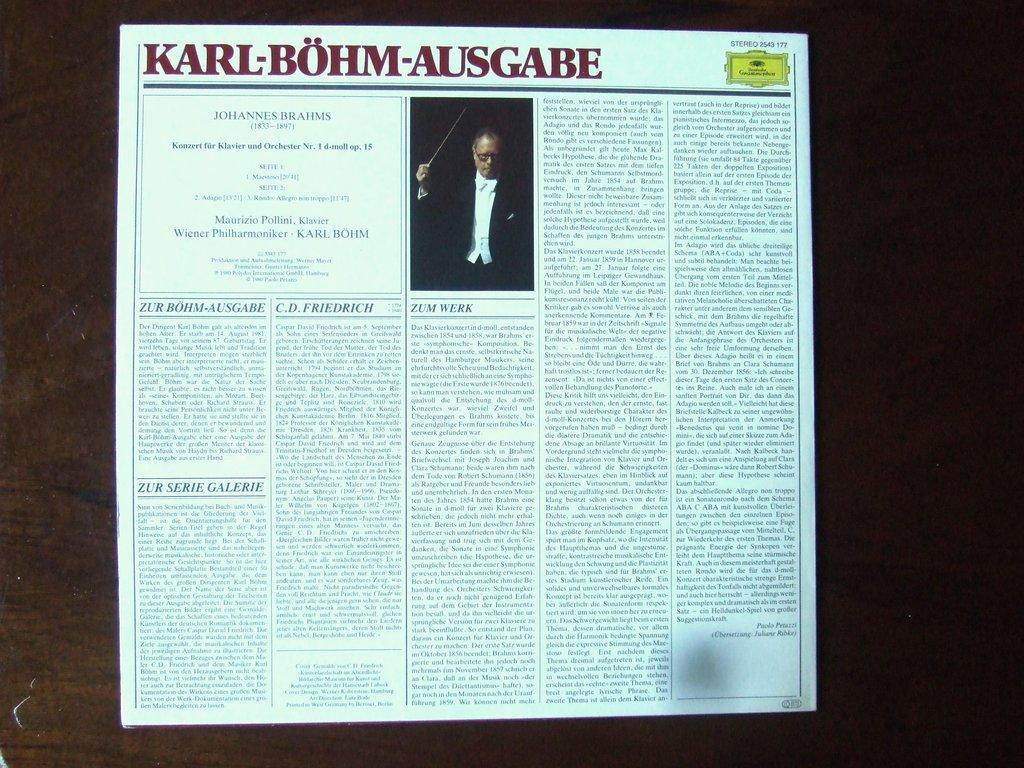<image>
Present a compact description of the photo's key features. The news article is titled Karl Bohm Ausgabe. 